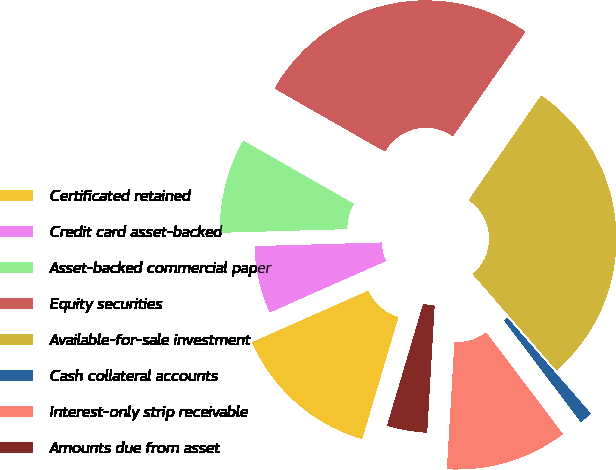Convert chart. <chart><loc_0><loc_0><loc_500><loc_500><pie_chart><fcel>Certificated retained<fcel>Credit card asset-backed<fcel>Asset-backed commercial paper<fcel>Equity securities<fcel>Available-for-sale investment<fcel>Cash collateral accounts<fcel>Interest-only strip receivable<fcel>Amounts due from asset<nl><fcel>13.77%<fcel>6.18%<fcel>8.71%<fcel>26.4%<fcel>28.93%<fcel>1.12%<fcel>11.24%<fcel>3.65%<nl></chart> 